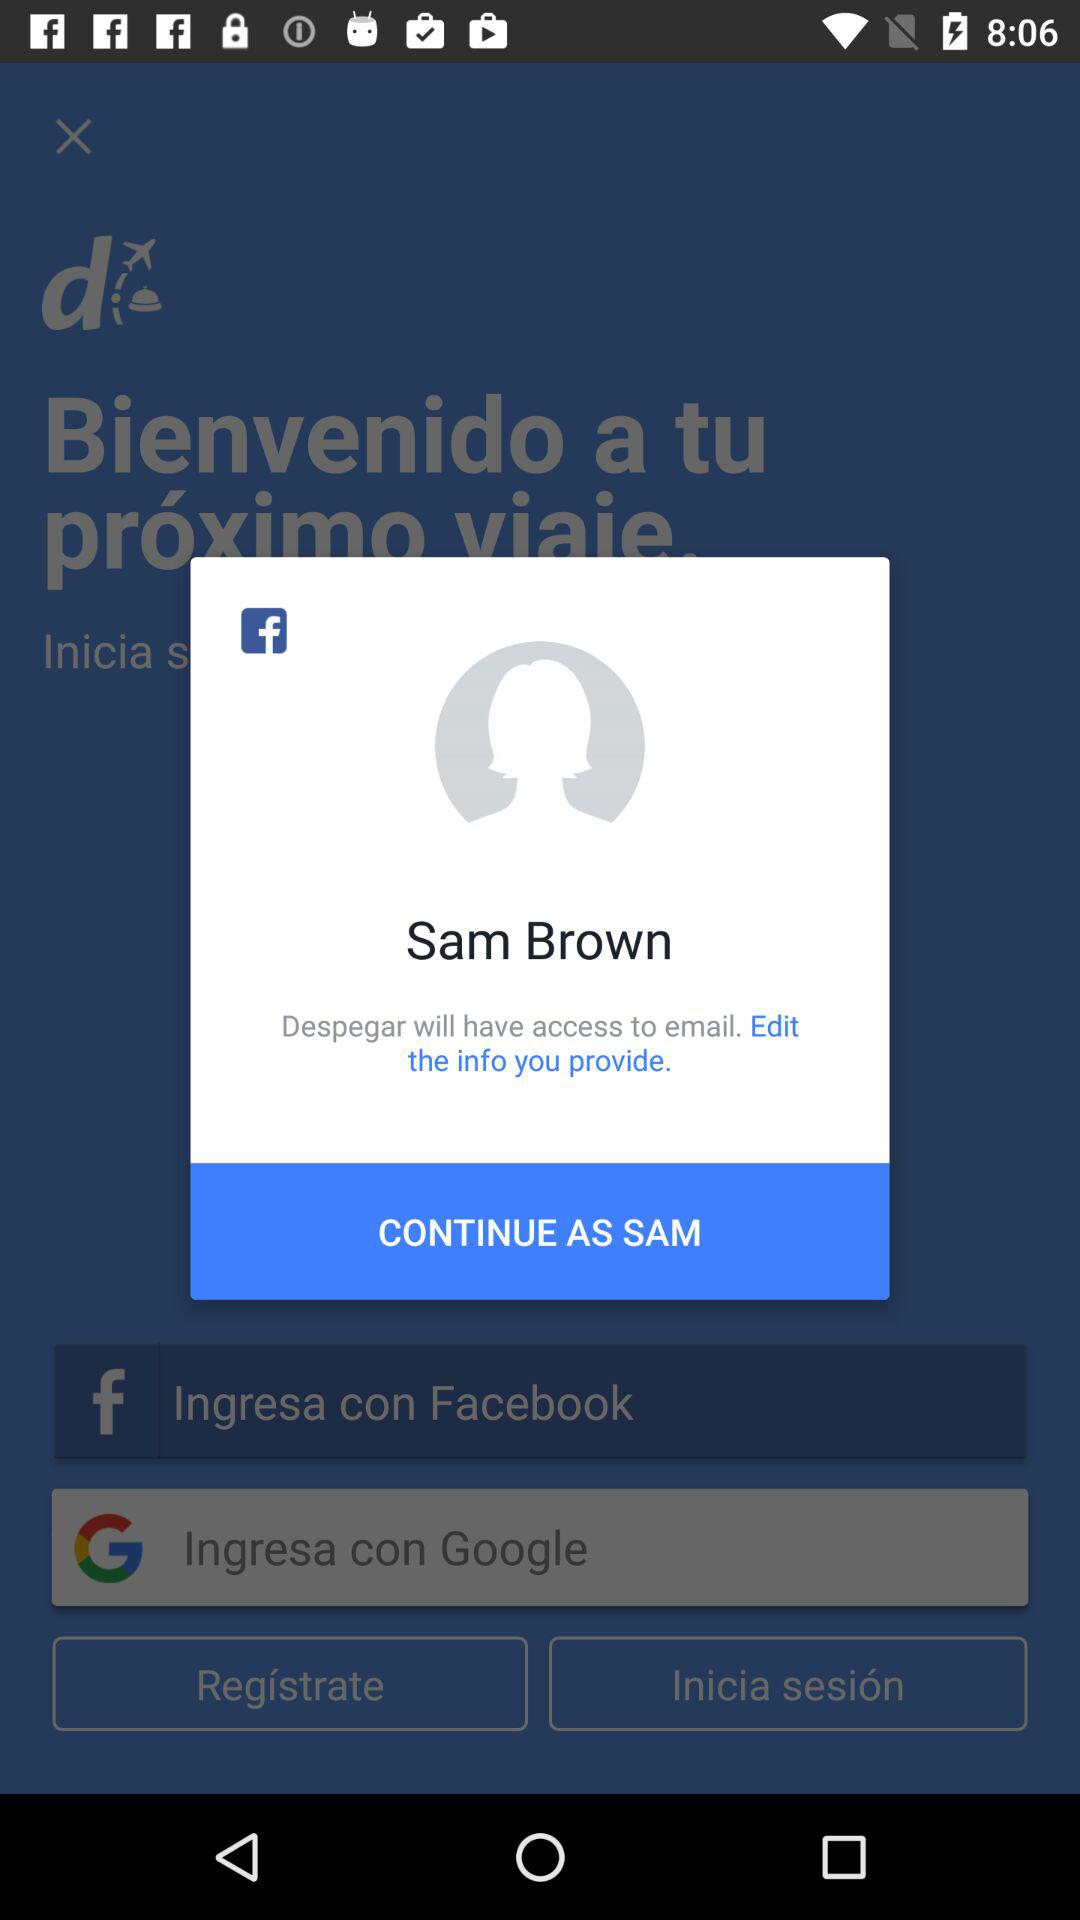What is the name of the user? The name of the user is Sam Brown. 